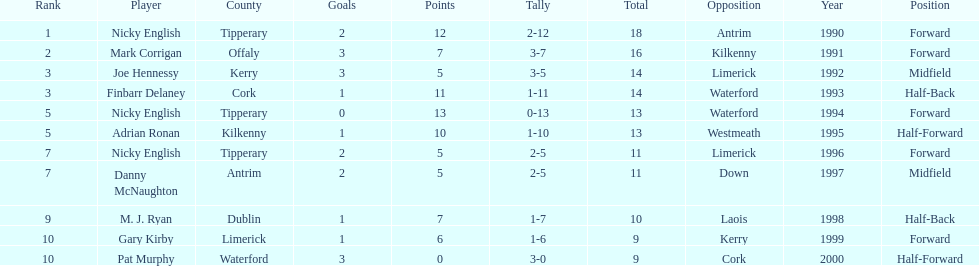Who was the top ranked player in a single game? Nicky English. 